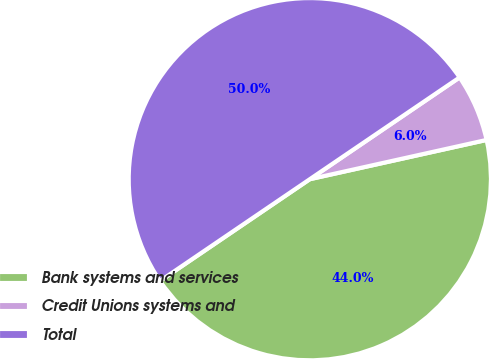Convert chart to OTSL. <chart><loc_0><loc_0><loc_500><loc_500><pie_chart><fcel>Bank systems and services<fcel>Credit Unions systems and<fcel>Total<nl><fcel>43.98%<fcel>6.02%<fcel>50.0%<nl></chart> 